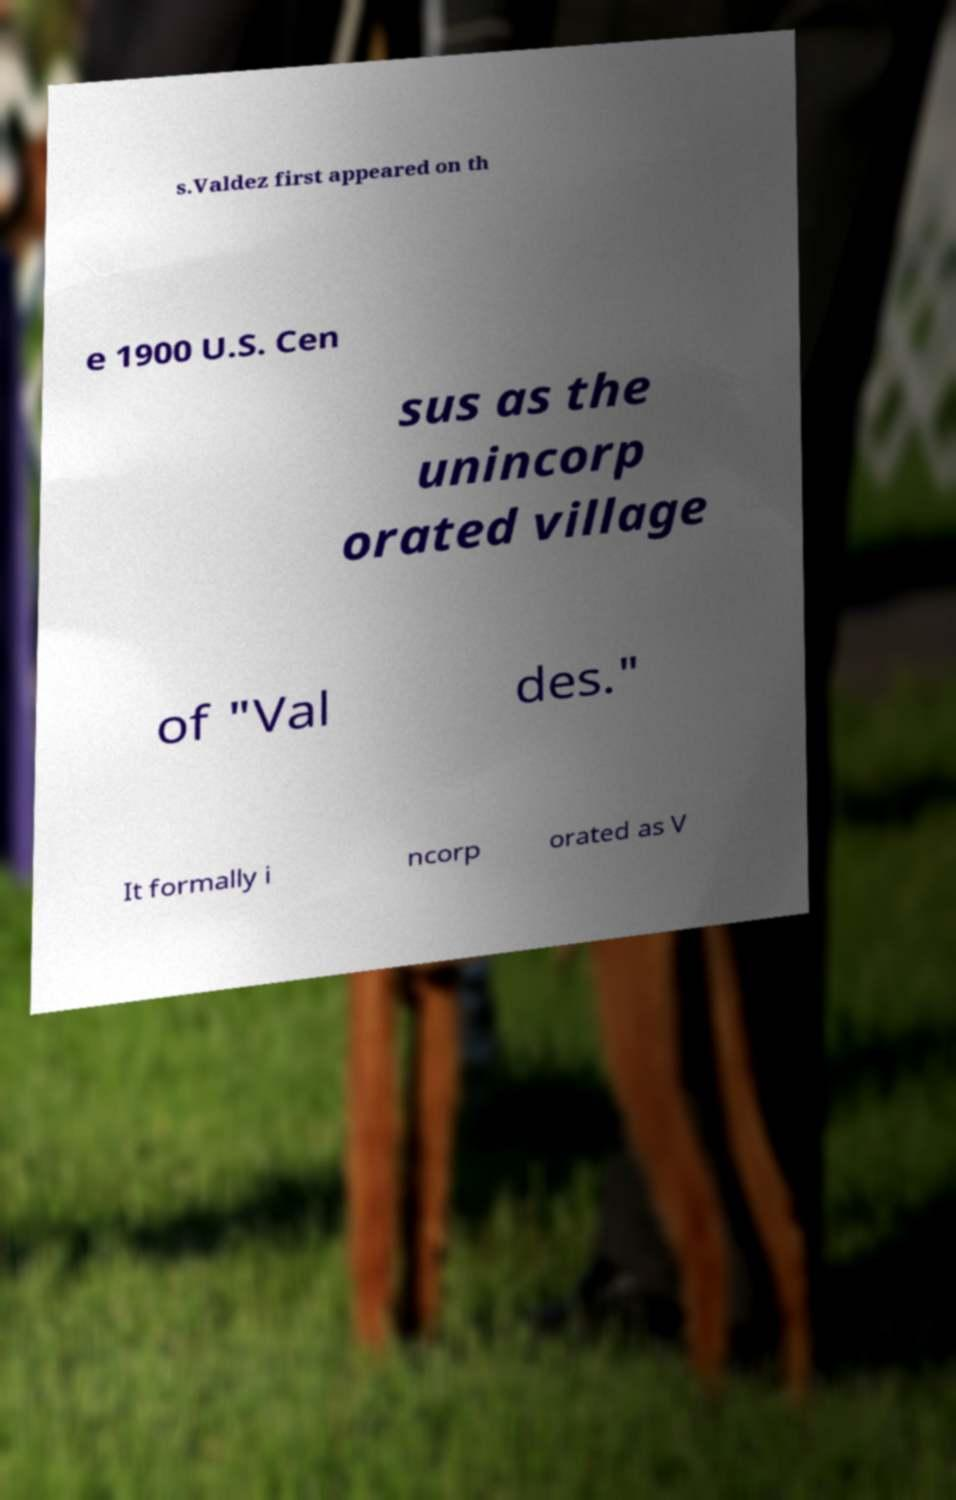For documentation purposes, I need the text within this image transcribed. Could you provide that? s.Valdez first appeared on th e 1900 U.S. Cen sus as the unincorp orated village of "Val des." It formally i ncorp orated as V 